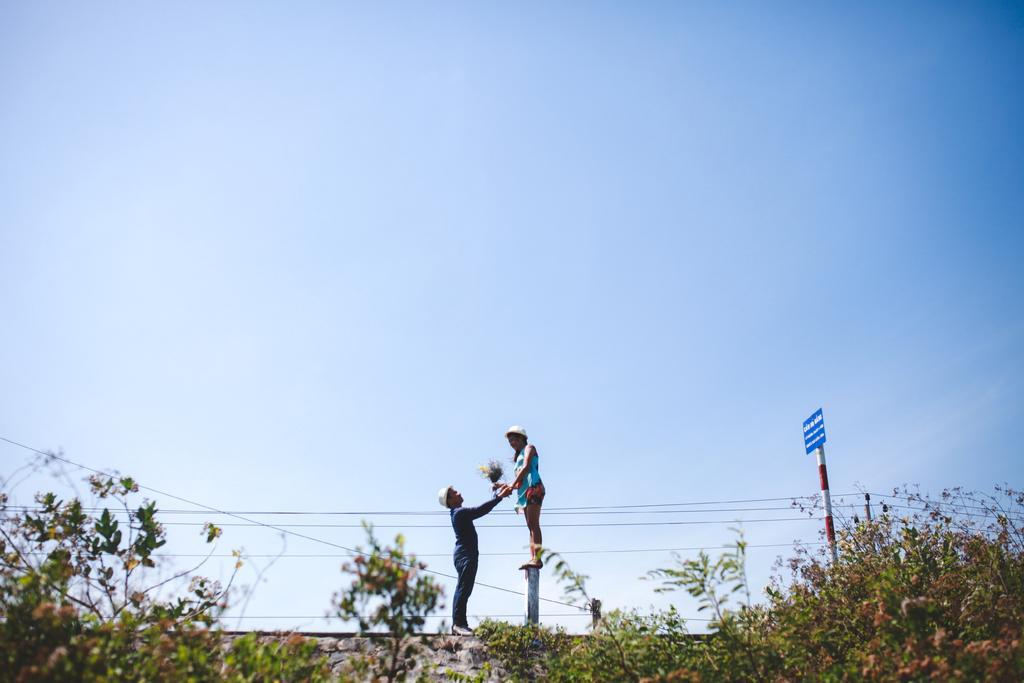Could you give a brief overview of what you see in this image? In this image we can see two persons holding an object, there are some trees, wires and a pole with a board, on the board, we can see some text and in the background, we can see the sky. 